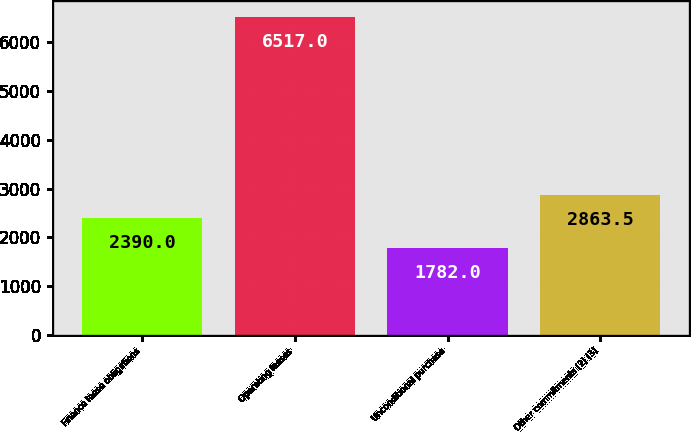<chart> <loc_0><loc_0><loc_500><loc_500><bar_chart><fcel>Finance lease obligations<fcel>Operating leases<fcel>Unconditional purchase<fcel>Other commitments (2) (3)<nl><fcel>2390<fcel>6517<fcel>1782<fcel>2863.5<nl></chart> 